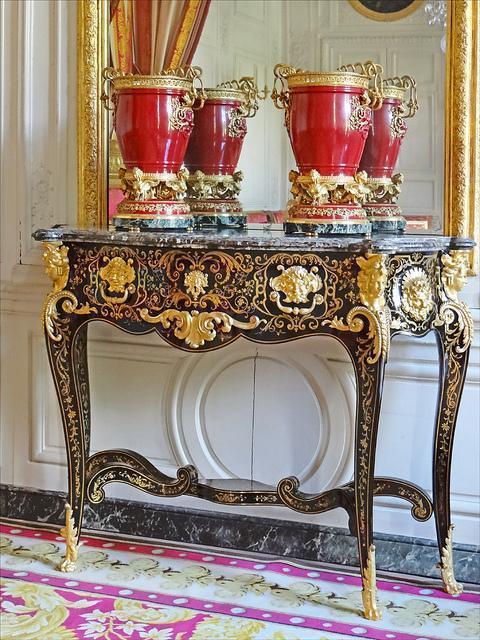How many vases can you see?
Give a very brief answer. 4. How many people posing for picture?
Give a very brief answer. 0. 